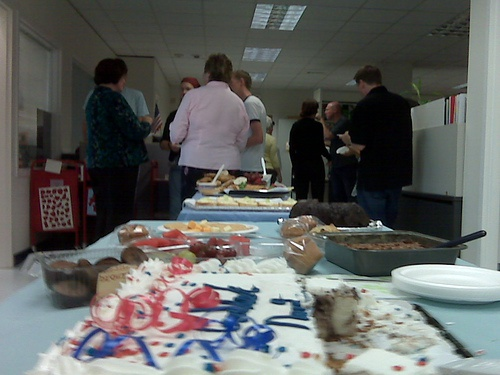Describe the objects in this image and their specific colors. I can see cake in gray, lightgray, darkgray, and brown tones, people in gray and black tones, people in gray, black, and purple tones, people in gray and black tones, and bowl in gray and black tones in this image. 